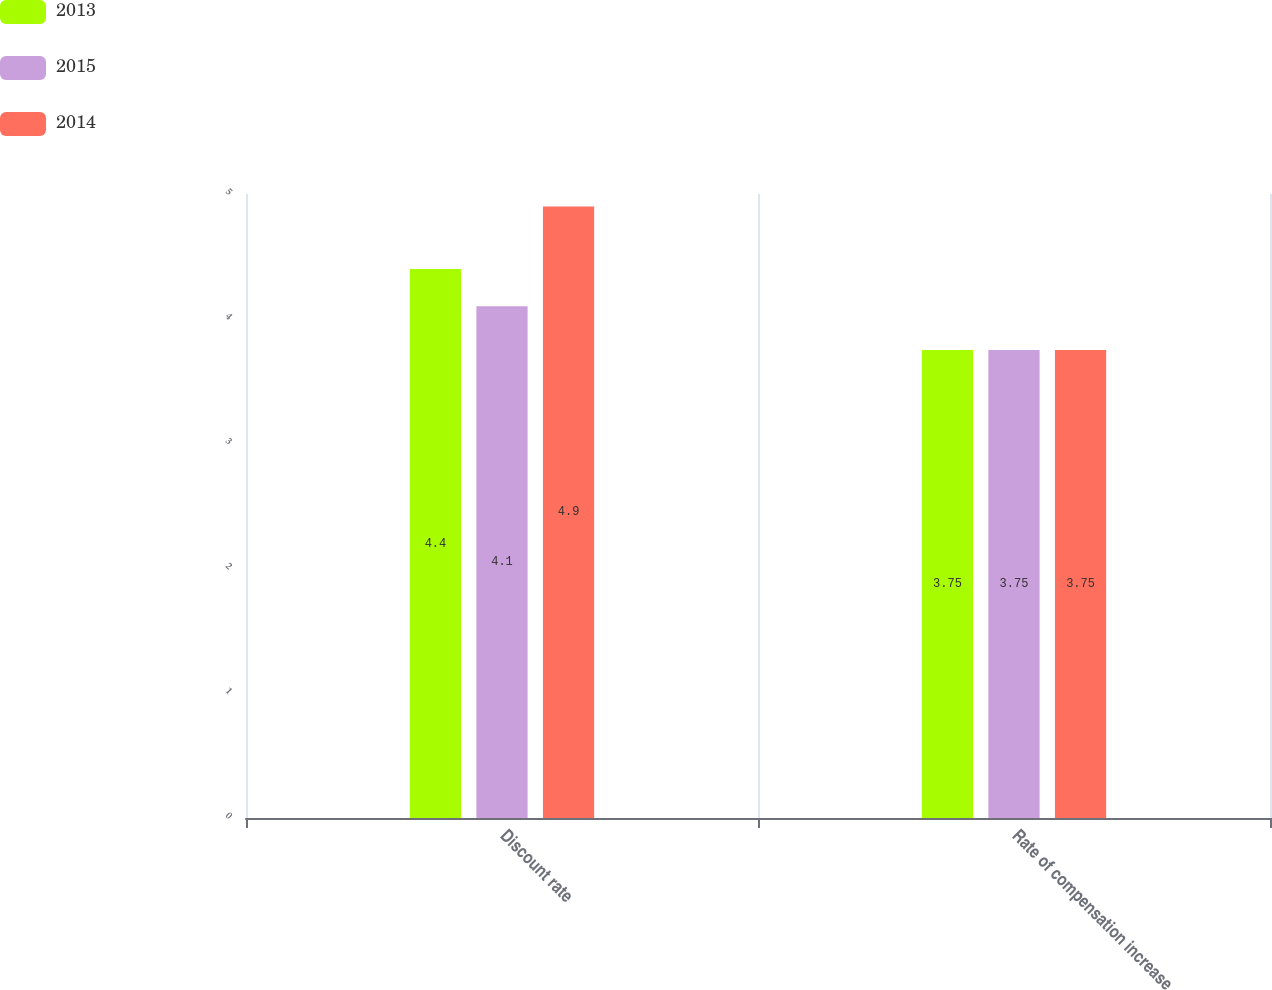<chart> <loc_0><loc_0><loc_500><loc_500><stacked_bar_chart><ecel><fcel>Discount rate<fcel>Rate of compensation increase<nl><fcel>2013<fcel>4.4<fcel>3.75<nl><fcel>2015<fcel>4.1<fcel>3.75<nl><fcel>2014<fcel>4.9<fcel>3.75<nl></chart> 